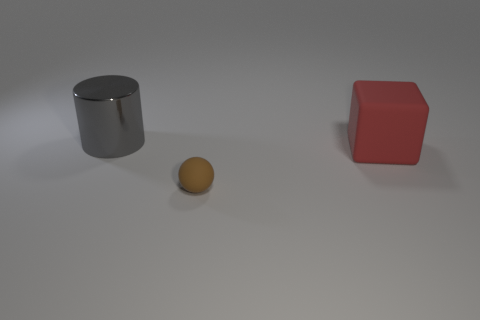How do the textures of the objects differ? The metallic cylinder has a smooth and reflective texture, likely indicating it's made of a polished material. In contrast, the red cube looks to have a more matte finish, with slight imperfections visible, which might suggest a plastic or painted wood composition. The sphere seems to have a texture akin to a rubber or matte painted surface, due to its non-reflective but smooth appearance. 